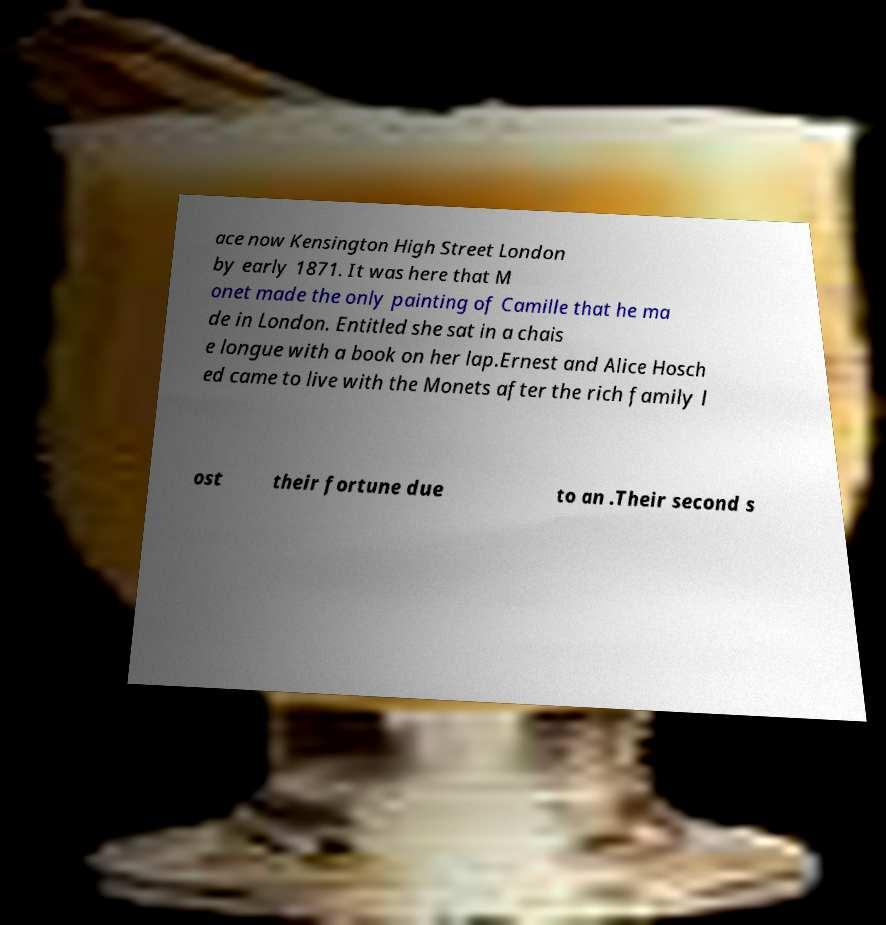Can you read and provide the text displayed in the image?This photo seems to have some interesting text. Can you extract and type it out for me? ace now Kensington High Street London by early 1871. It was here that M onet made the only painting of Camille that he ma de in London. Entitled she sat in a chais e longue with a book on her lap.Ernest and Alice Hosch ed came to live with the Monets after the rich family l ost their fortune due to an .Their second s 